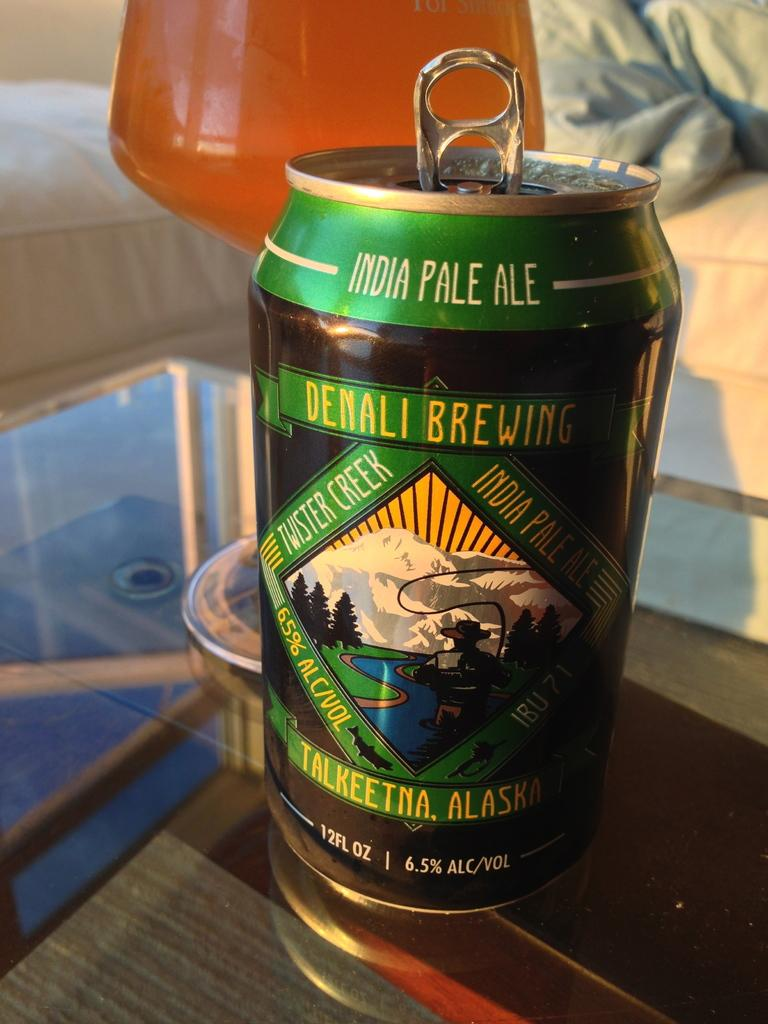What object is on the table in the image? There is a tin on the table. What else can be seen on the table? There is a glass with liquid on the table. What type of furniture is visible in the background of the image? There is a sofa in the background of the image. What word is being cast as a spell on the tin in the image? There is no indication of any magic or spells in the image; it simply shows a tin and a glass with liquid on a table. 